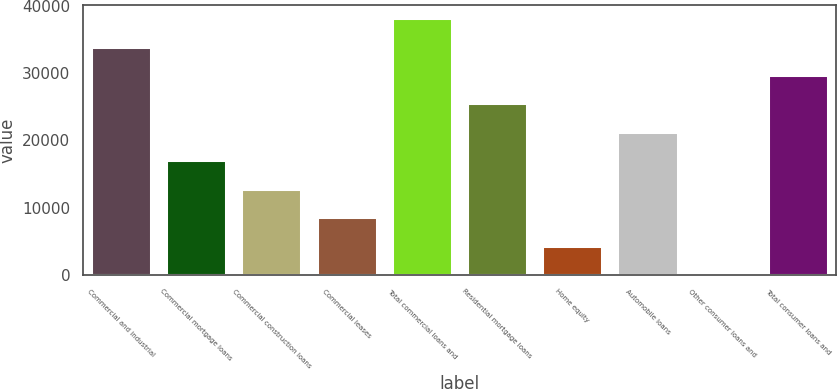Convert chart. <chart><loc_0><loc_0><loc_500><loc_500><bar_chart><fcel>Commercial and industrial<fcel>Commercial mortgage loans<fcel>Commercial construction loans<fcel>Commercial leases<fcel>Total commercial loans and<fcel>Residential mortgage loans<fcel>Home equity<fcel>Automobile loans<fcel>Other consumer loans and<fcel>Total consumer loans and<nl><fcel>33930.2<fcel>17032.6<fcel>12808.2<fcel>8583.8<fcel>38154.6<fcel>25481.4<fcel>4359.4<fcel>21257<fcel>135<fcel>29705.8<nl></chart> 